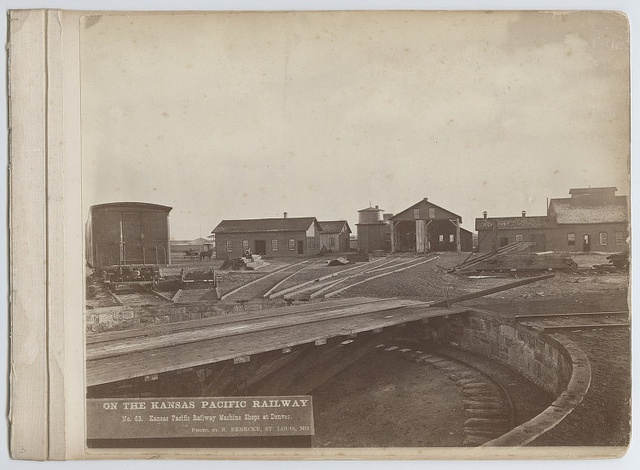Describe the objects in this image and their specific colors. I can see train in lightgray, gray, maroon, and darkgray tones and horse in lightgray, gray, and black tones in this image. 